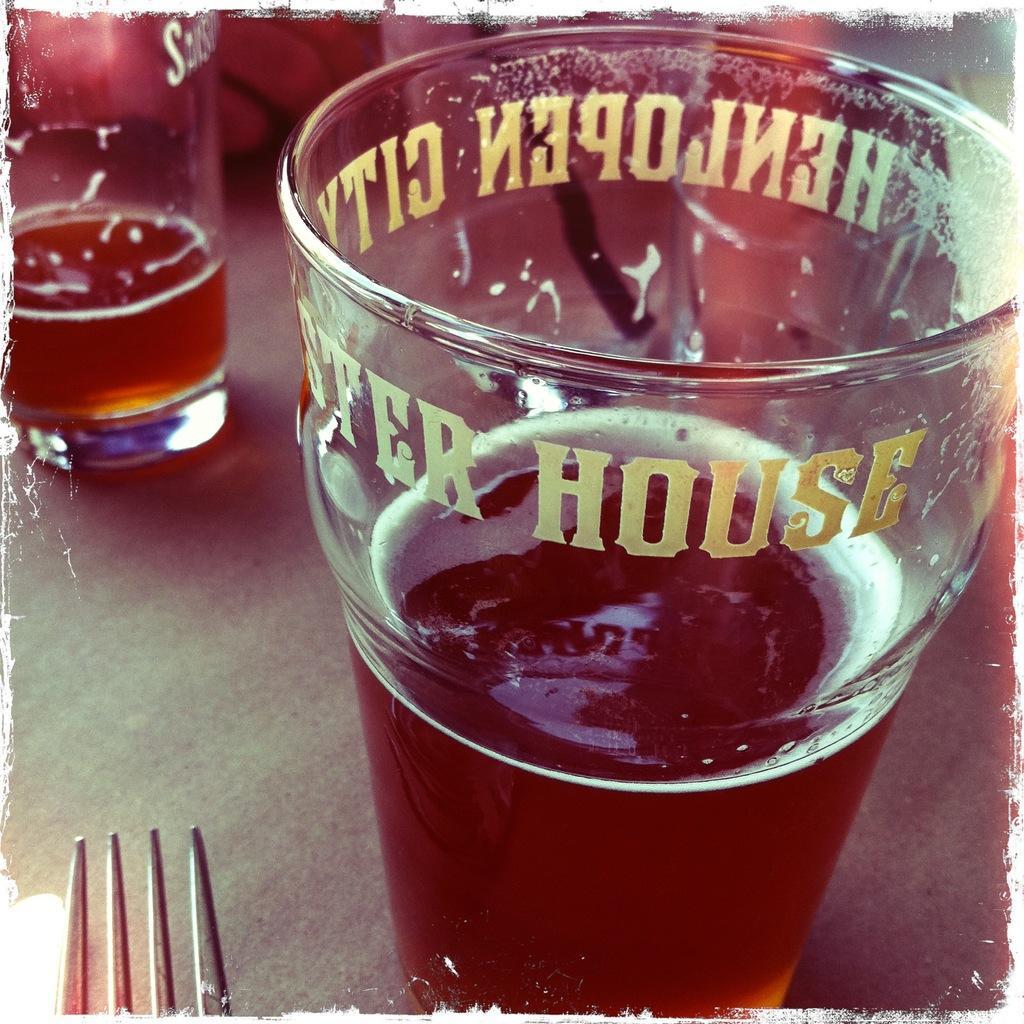Can you describe this image briefly? In this image we can see glasses which contains bear and fork are present on the table. 